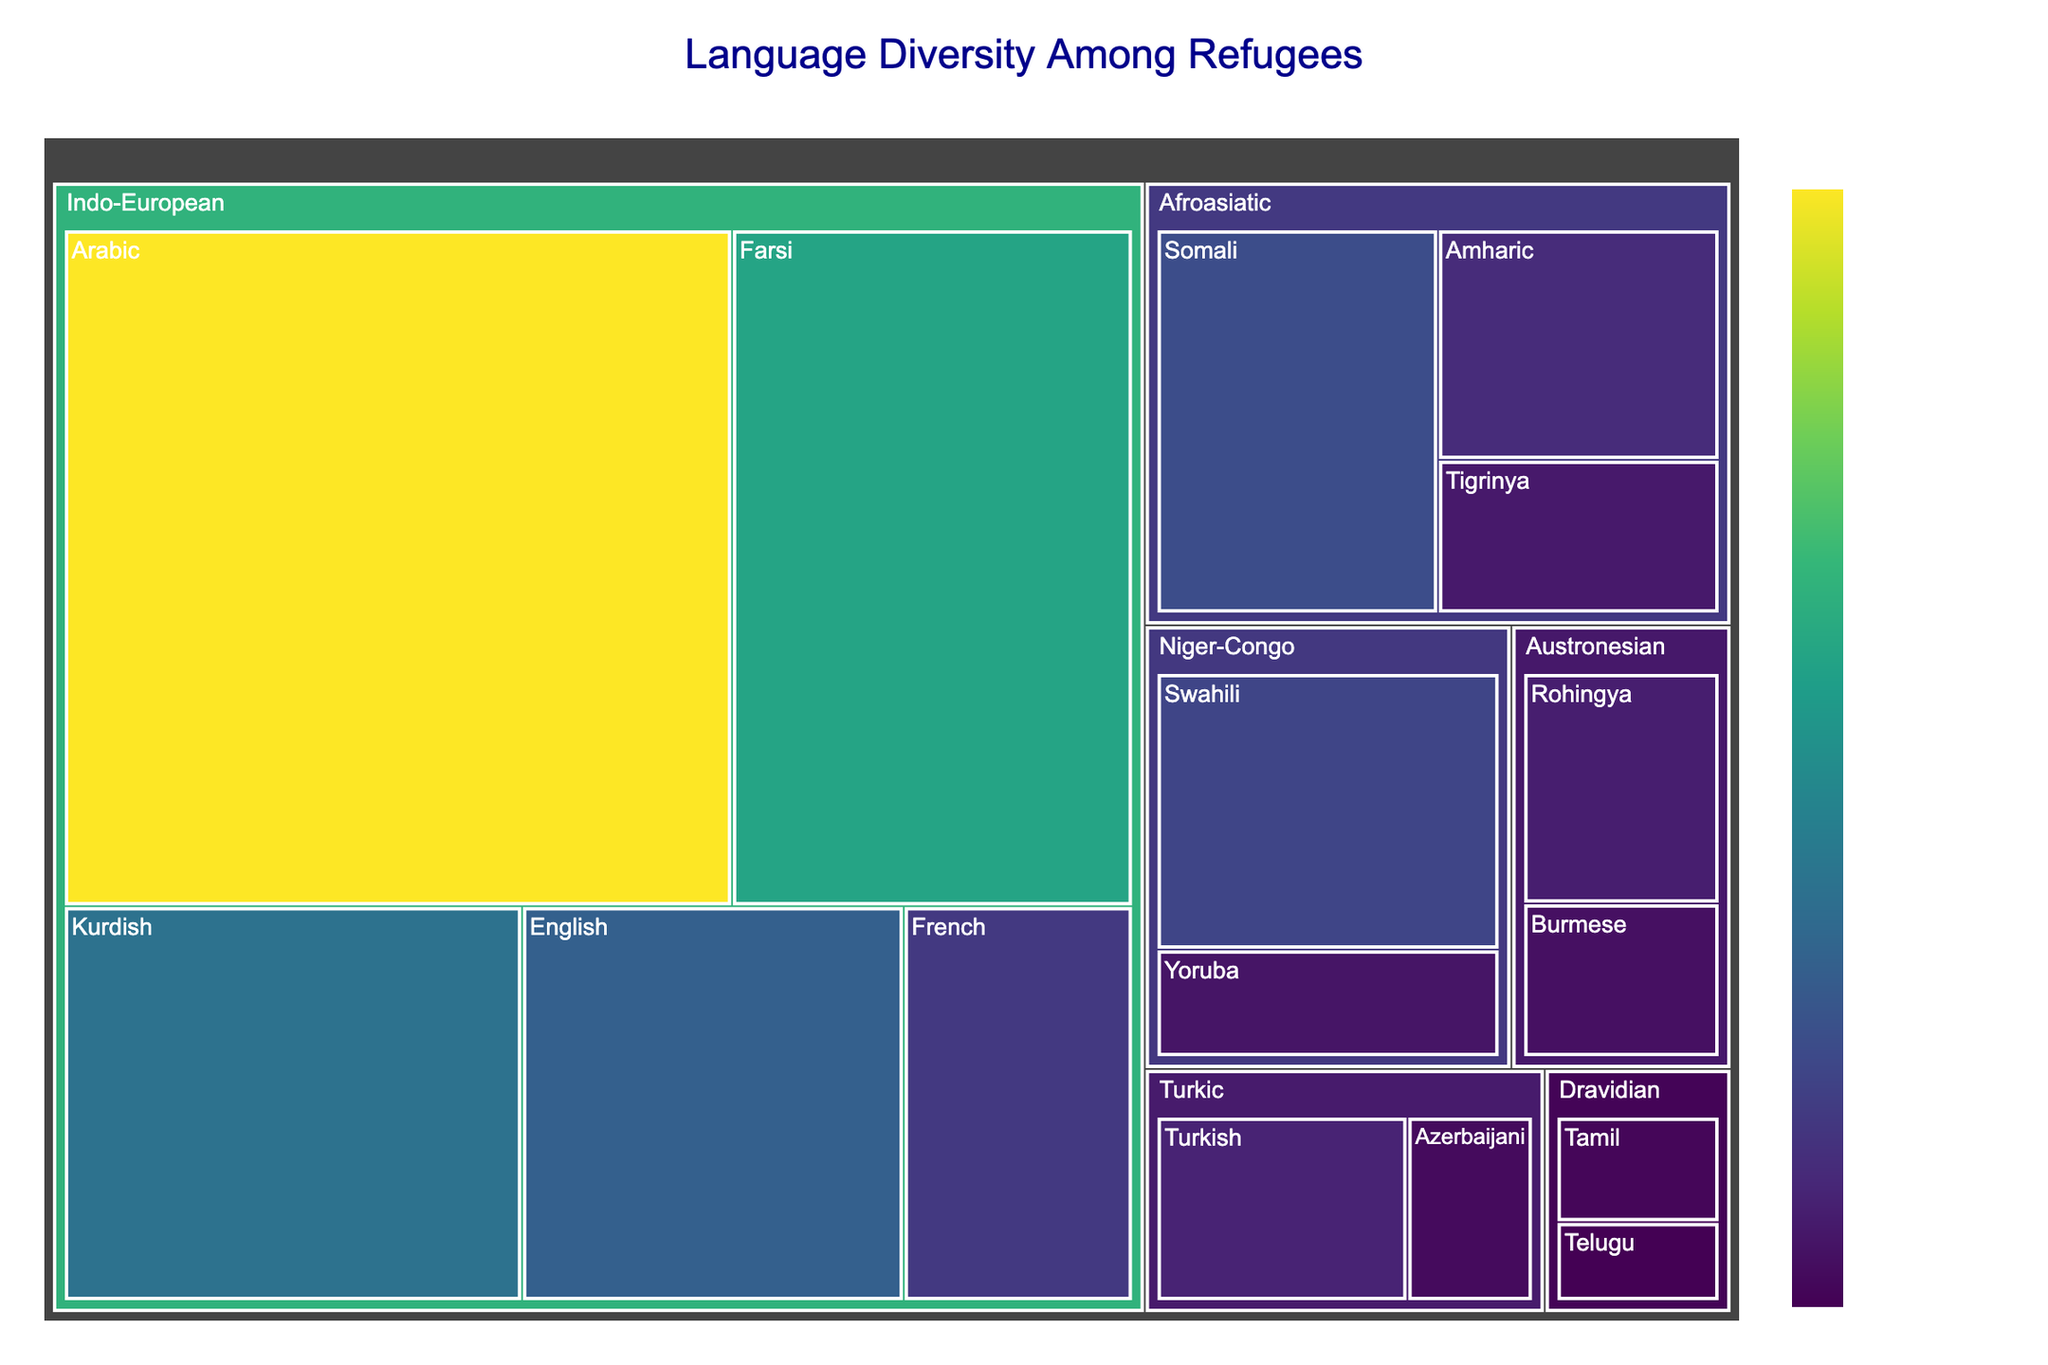Which language family has the highest number of speakers overall? To find the language family with the highest number of speakers overall, add up the number of speakers for each language in that family and compare totals. For Indo-European: Arabic (75000) + Farsi (45000) + Kurdish (30000) + English (25000) + French (15000) = 190000 speakers. Compare this with other language families.
Answer: Indo-European What is the title of the treemap? The title is usually displayed at the top center of the figure.
Answer: Language Diversity Among Refugees Which individual language has the highest number of speakers? Look at the treemap for the language block with the highest value. In this case, Arabic in the Indo-European family has 75000 speakers.
Answer: Arabic How many speakers are there in the Afroasiatic language family? Sum the number of speakers for all languages in the Afroasiatic family: Somali (20000) + Amharic (12000) + Tigrinya (8000) = 40000.
Answer: 40000 Which is greater: the number of Arabic speakers or the combined number of Tamil and Telugu speakers? Compare the number of Arabic speakers (75000) with the sum of Tamil (4000) and Telugu (3000): 75000 vs (4000 + 3000 = 7000).
Answer: Arabic speakers Which language family has the least total number of speakers? Add the number of speakers for all languages in each family, the family with the smallest total is: Dravidian: Tamil (4000) + Telugu (3000) = 7000.
Answer: Dravidian What is the color schema used to represent the number of speakers in the treemap? The color schema is usually mentioned in the legend or in the color bar title. In this case, it is the Viridis color scale.
Answer: Viridis What is the average number of speakers per language in the Niger-Congo family? Calculate the sum of the number of speakers in the Niger-Congo family: Swahili (18000) + Yoruba (7000) = 25000. Divide by the number of languages: 25000 / 2 = 12500.
Answer: 12500 How many languages are represented in the Indo-European language family? Count the number of language blocks within the Indo-European family in the treemap: Arabic, Farsi, Kurdish, English, French which are 5 languages.
Answer: 5 What's the difference between the number of Swahili speakers and the number of Tigrinya speakers? Subtract the number of Tigrinya speakers (8000) from the number of Swahili speakers (18000): 18000 - 8000 = 10000.
Answer: 10000 